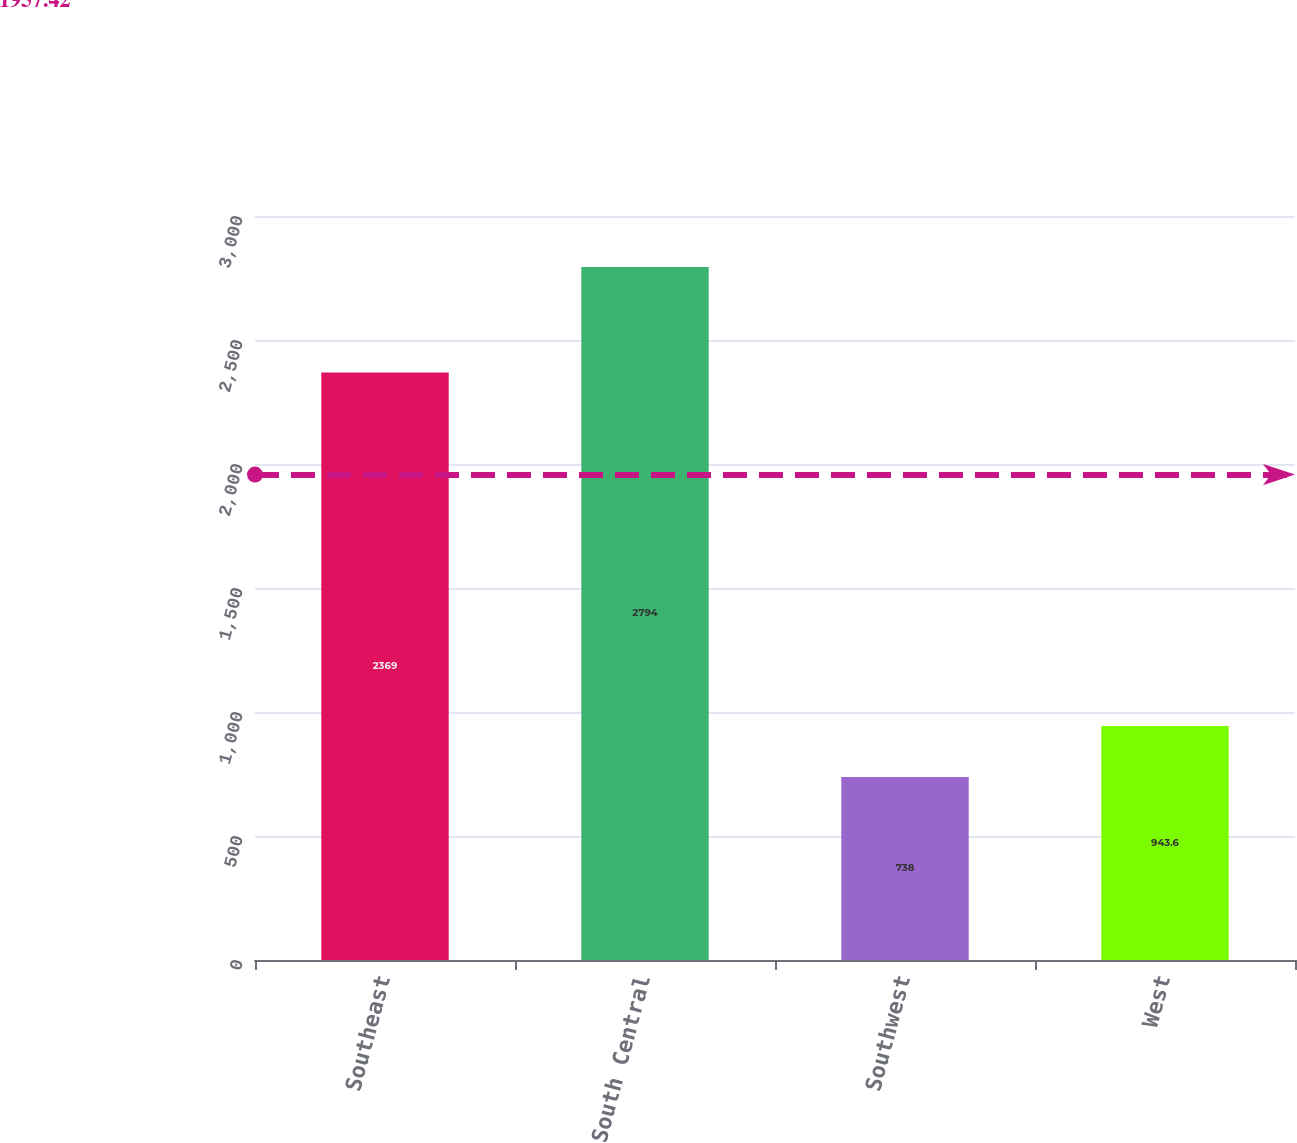Convert chart to OTSL. <chart><loc_0><loc_0><loc_500><loc_500><bar_chart><fcel>Southeast<fcel>South Central<fcel>Southwest<fcel>West<nl><fcel>2369<fcel>2794<fcel>738<fcel>943.6<nl></chart> 